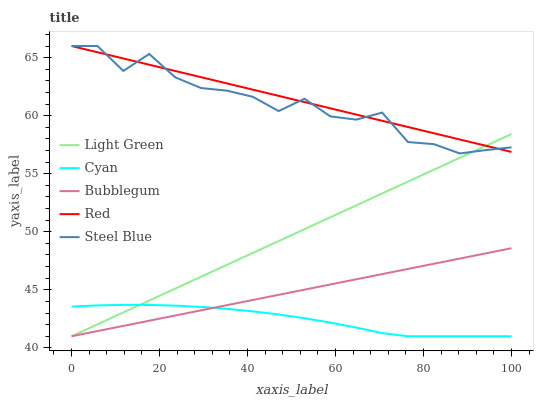Does Cyan have the minimum area under the curve?
Answer yes or no. Yes. Does Red have the maximum area under the curve?
Answer yes or no. Yes. Does Bubblegum have the minimum area under the curve?
Answer yes or no. No. Does Bubblegum have the maximum area under the curve?
Answer yes or no. No. Is Bubblegum the smoothest?
Answer yes or no. Yes. Is Steel Blue the roughest?
Answer yes or no. Yes. Is Red the smoothest?
Answer yes or no. No. Is Red the roughest?
Answer yes or no. No. Does Cyan have the lowest value?
Answer yes or no. Yes. Does Red have the lowest value?
Answer yes or no. No. Does Steel Blue have the highest value?
Answer yes or no. Yes. Does Bubblegum have the highest value?
Answer yes or no. No. Is Cyan less than Red?
Answer yes or no. Yes. Is Red greater than Cyan?
Answer yes or no. Yes. Does Light Green intersect Red?
Answer yes or no. Yes. Is Light Green less than Red?
Answer yes or no. No. Is Light Green greater than Red?
Answer yes or no. No. Does Cyan intersect Red?
Answer yes or no. No. 